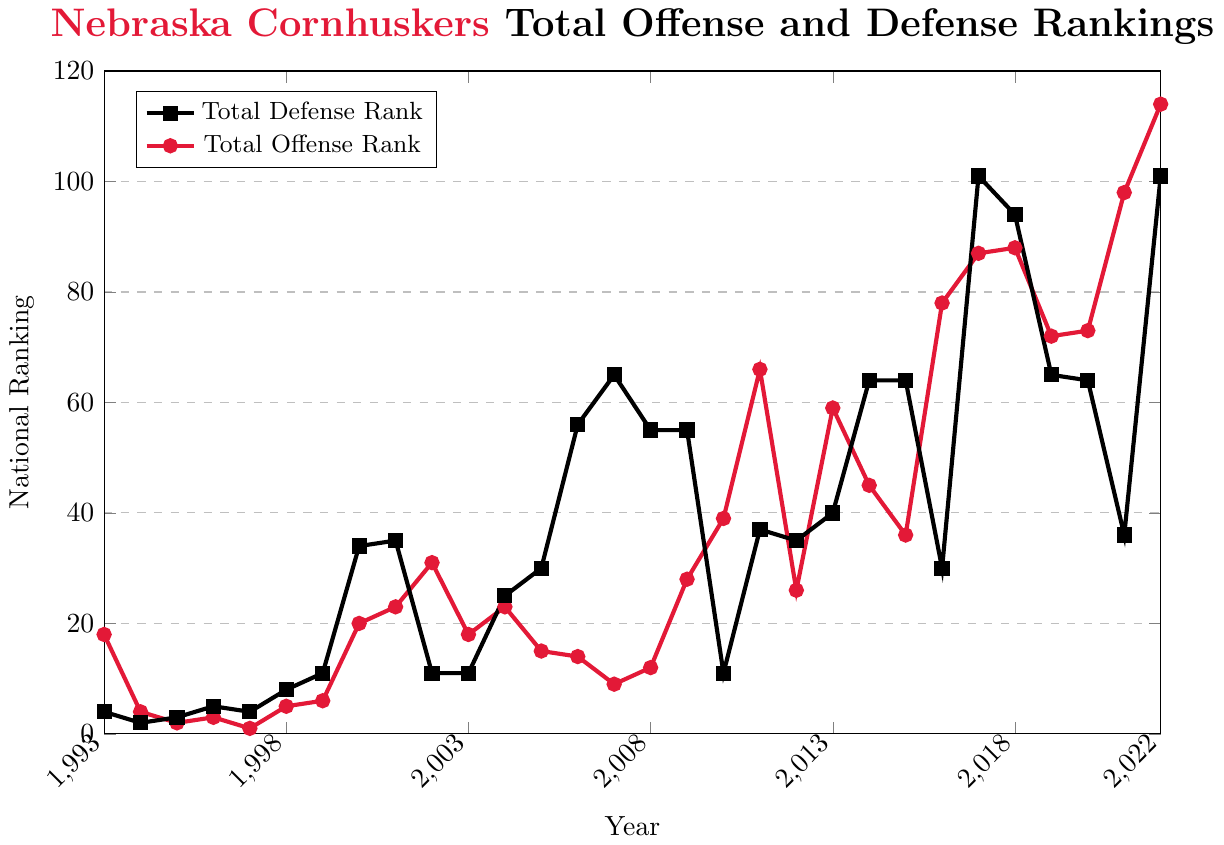What is the best national ranking achieved by Nebraska Cornhuskers in total offense and in which year? The best national ranking in total offense is the lowest value of "Total Offense Rank". From the data, the lowest value is 1, which occurred in the year 1997.
Answer: 1 in 1997 Which year did Nebraska Cornhuskers achieve the lowest total defense rank? The lowest total defense rank is the highest numerical value in "Total Defense Rank". From the data, the highest value is 101, which occurred in the years 2017 and 2022.
Answer: 2017 and 2022 In which year is the gap between offense and defense ranks the largest? Calculate the absolute difference between offense and defense ranks for each year and identify the year with the largest difference. The year 2007 has the largest gap with (65 - 9) = 56.
Answer: 2007 On average, which performance is better over the last 30 seasons, offense or defense? First, calculate the average ranks for both offense and defense. The sum of all offense ranks is 1238 and for defense ranks is 1382. Divide these by the number of seasons, 30. The average rank for offense is 41.27 and for defense is 46.07. Offense has the better average rank.
Answer: Offense In which years were both offense and defense simultaneously ranked in the top 10 nationally? Identify the years where both "Total Offense Rank" and "Total Defense Rank" are less than or equal to 10. From the data, the years are 1994, 1995, 1997, and 1998.
Answer: 1994, 1995, 1997, and 1998 Which has the most drastic drop in rank from one year to the next in total offense? Calculate the differences between consecutive years' offense ranks and find the largest positive difference. From the data, the biggest drop is from 2010 (rank 39) to 2011 (rank 66), a difference of 27.
Answer: 2011 Compare the Cornhuskers' best consecutive 5-year average ranking for offense versus defense. Compute the averages using overlapping 5-year windows and compare the best averages. The best 5-year average for offense is from 1994 to 1998 (average = (4+2+3+1+5)/5 = 3). For defense, the best 5-year average is from 1993 to 1997 (average = (4+2+3+5+4)/5 = 3.6). The offense has a slightly better best 5-year average.
Answer: Offense 